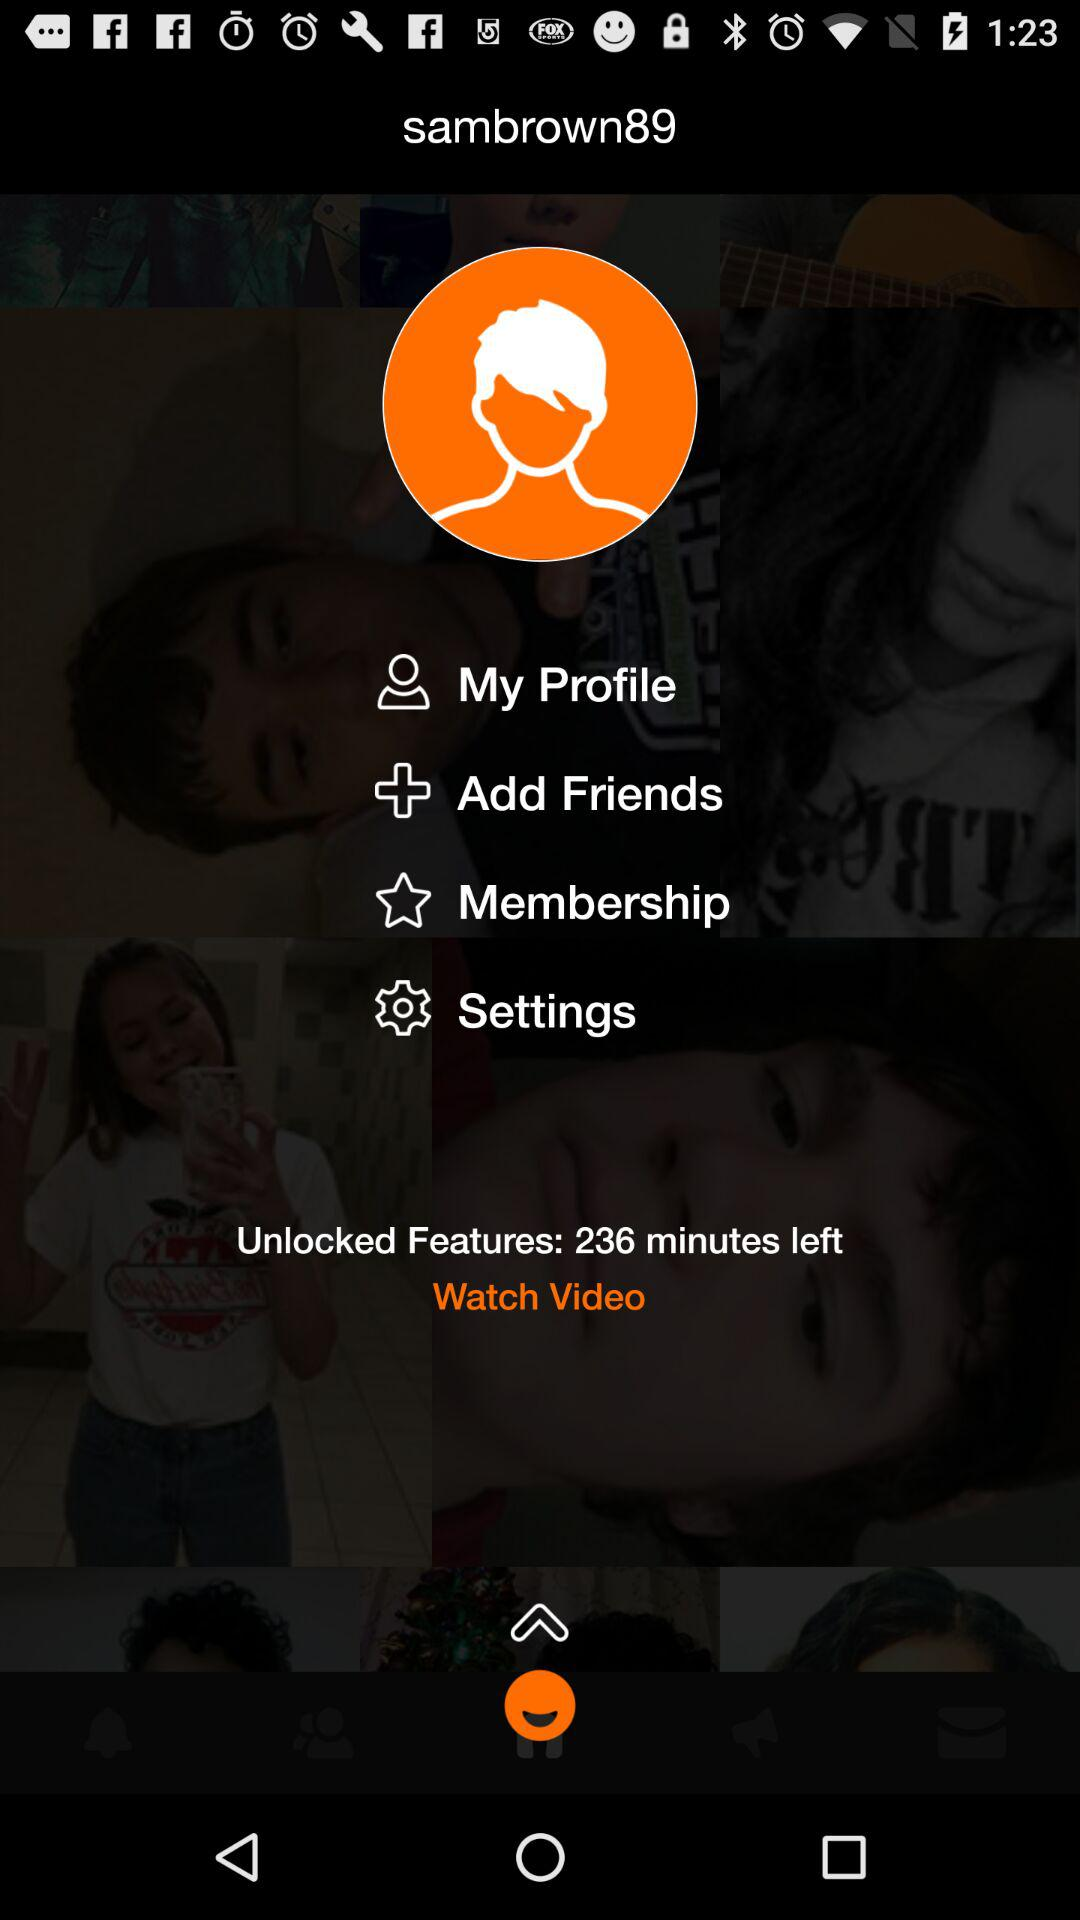How many items are below the profile picture?
Answer the question using a single word or phrase. 4 